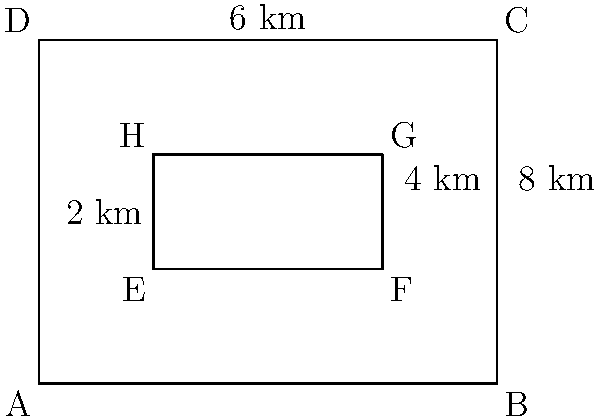A proposed nature reserve within your company's forested land is represented by the inner rectangle EFGH. If the outer rectangle ABCD represents the entire forested area with dimensions 8 km by 6 km, and the nature reserve is positioned 2 km from the left edge and bottom edge of the forest, what is the perimeter of the proposed nature reserve in kilometers? To calculate the perimeter of the proposed nature reserve (rectangle EFGH), we need to determine its dimensions and then sum up all sides.

Step 1: Calculate the width of EFGH
Width of EFGH = Width of ABCD - Left margin - Right margin
Width of EFGH = 8 km - 2 km - 2 km = 4 km

Step 2: Calculate the height of EFGH
Height of EFGH = Height of ABCD - Bottom margin - Top margin
Height of EFGH = 6 km - 2 km - 2 km = 2 km

Step 3: Calculate the perimeter of EFGH
Perimeter = 2 * (width + height)
Perimeter = 2 * (4 km + 2 km)
Perimeter = 2 * 6 km
Perimeter = 12 km

Therefore, the perimeter of the proposed nature reserve is 12 km.
Answer: 12 km 